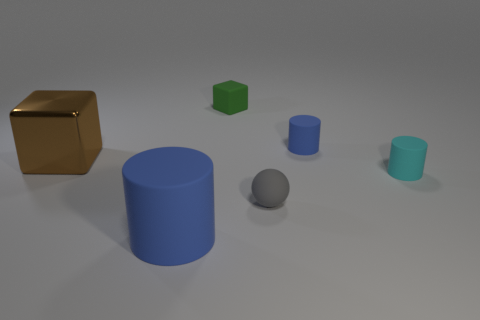Is there anything else that is the same material as the large brown thing?
Ensure brevity in your answer.  No. Are there more large rubber things than tiny green matte cylinders?
Give a very brief answer. Yes. Does the sphere have the same material as the big brown block?
Offer a terse response. No. Is the number of small blue things left of the large brown metal block the same as the number of yellow rubber cubes?
Provide a short and direct response. Yes. How many large things are made of the same material as the tiny gray sphere?
Provide a short and direct response. 1. Are there fewer small green rubber things than yellow metallic objects?
Provide a short and direct response. No. Is the color of the rubber cylinder that is on the right side of the small blue object the same as the large rubber object?
Offer a terse response. No. What number of blocks are left of the blue cylinder in front of the matte cylinder behind the cyan matte cylinder?
Ensure brevity in your answer.  1. What number of tiny things are behind the big brown shiny cube?
Ensure brevity in your answer.  2. What is the color of the other small object that is the same shape as the tiny cyan rubber object?
Offer a terse response. Blue. 